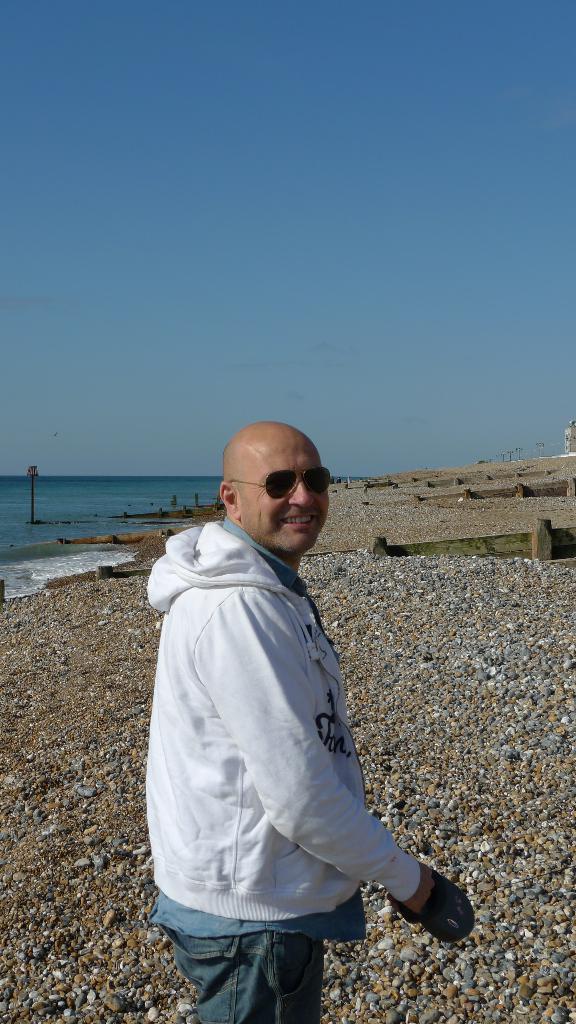Could you give a brief overview of what you see in this image? In this picture I can see a man and he is wearing sunglasses and holding something in his hand and I can see water and few stones on the ground and I can see blue sky. 